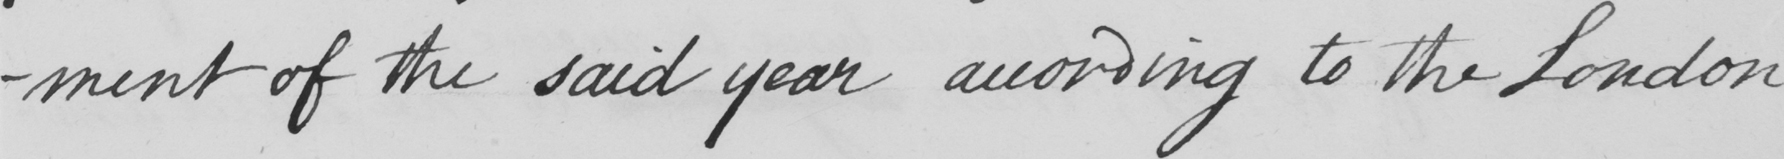Please provide the text content of this handwritten line. -ment of the said year according to the London 